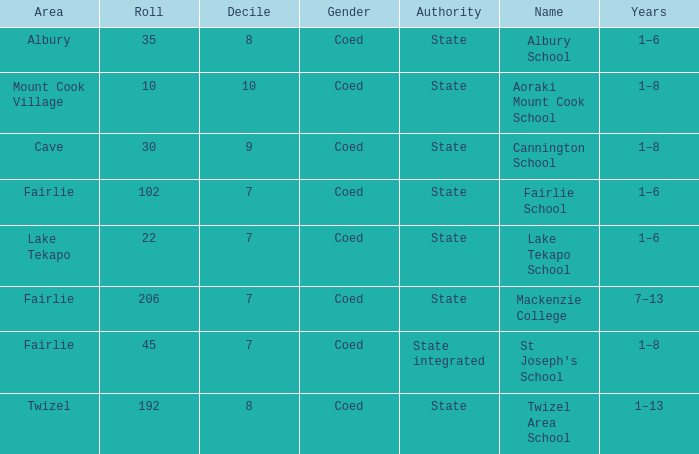What area is named Mackenzie college? Fairlie. 